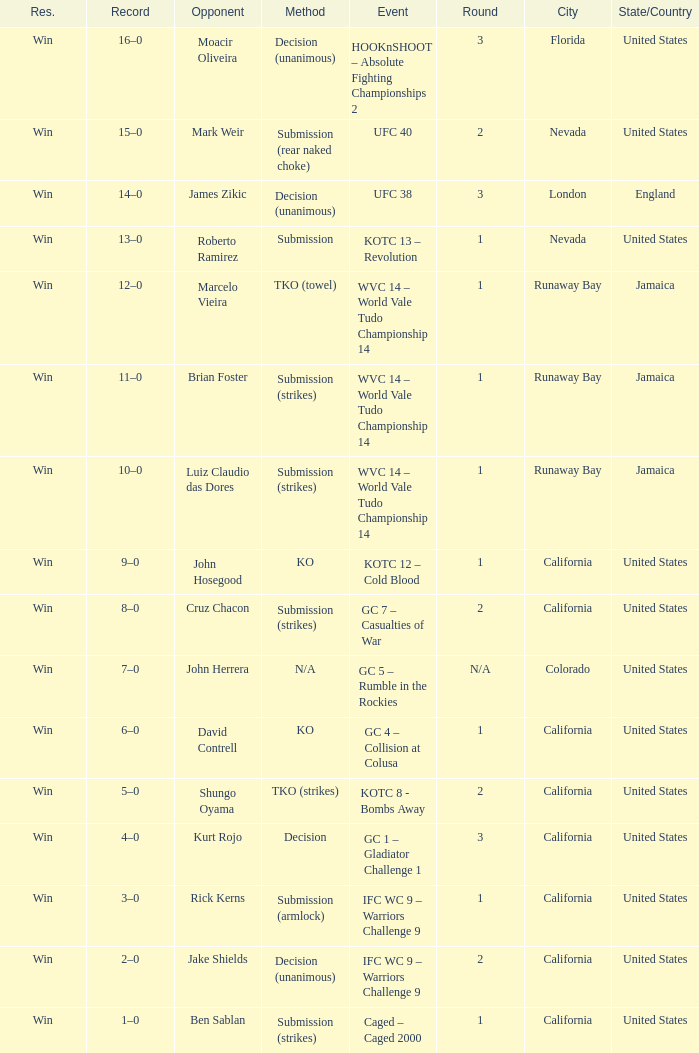Where was the fight located that lasted 1 round against luiz claudio das dores? Runaway Bay , Jamaica. 